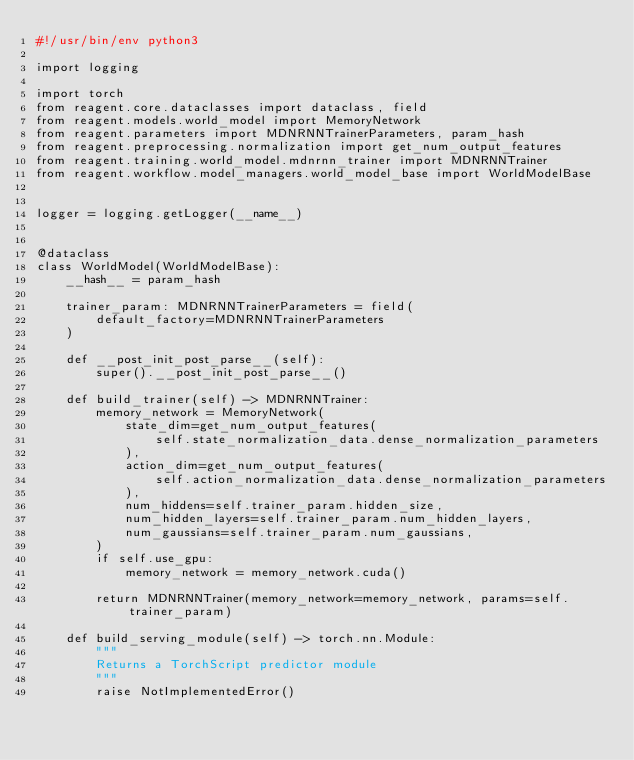<code> <loc_0><loc_0><loc_500><loc_500><_Python_>#!/usr/bin/env python3

import logging

import torch
from reagent.core.dataclasses import dataclass, field
from reagent.models.world_model import MemoryNetwork
from reagent.parameters import MDNRNNTrainerParameters, param_hash
from reagent.preprocessing.normalization import get_num_output_features
from reagent.training.world_model.mdnrnn_trainer import MDNRNNTrainer
from reagent.workflow.model_managers.world_model_base import WorldModelBase


logger = logging.getLogger(__name__)


@dataclass
class WorldModel(WorldModelBase):
    __hash__ = param_hash

    trainer_param: MDNRNNTrainerParameters = field(
        default_factory=MDNRNNTrainerParameters
    )

    def __post_init_post_parse__(self):
        super().__post_init_post_parse__()

    def build_trainer(self) -> MDNRNNTrainer:
        memory_network = MemoryNetwork(
            state_dim=get_num_output_features(
                self.state_normalization_data.dense_normalization_parameters
            ),
            action_dim=get_num_output_features(
                self.action_normalization_data.dense_normalization_parameters
            ),
            num_hiddens=self.trainer_param.hidden_size,
            num_hidden_layers=self.trainer_param.num_hidden_layers,
            num_gaussians=self.trainer_param.num_gaussians,
        )
        if self.use_gpu:
            memory_network = memory_network.cuda()

        return MDNRNNTrainer(memory_network=memory_network, params=self.trainer_param)

    def build_serving_module(self) -> torch.nn.Module:
        """
        Returns a TorchScript predictor module
        """
        raise NotImplementedError()
</code> 